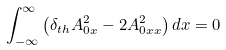<formula> <loc_0><loc_0><loc_500><loc_500>\int _ { - \infty } ^ { \infty } \left ( \delta _ { t h } A _ { 0 x } ^ { 2 } - 2 A _ { 0 x x } ^ { 2 } \right ) d x = 0</formula> 